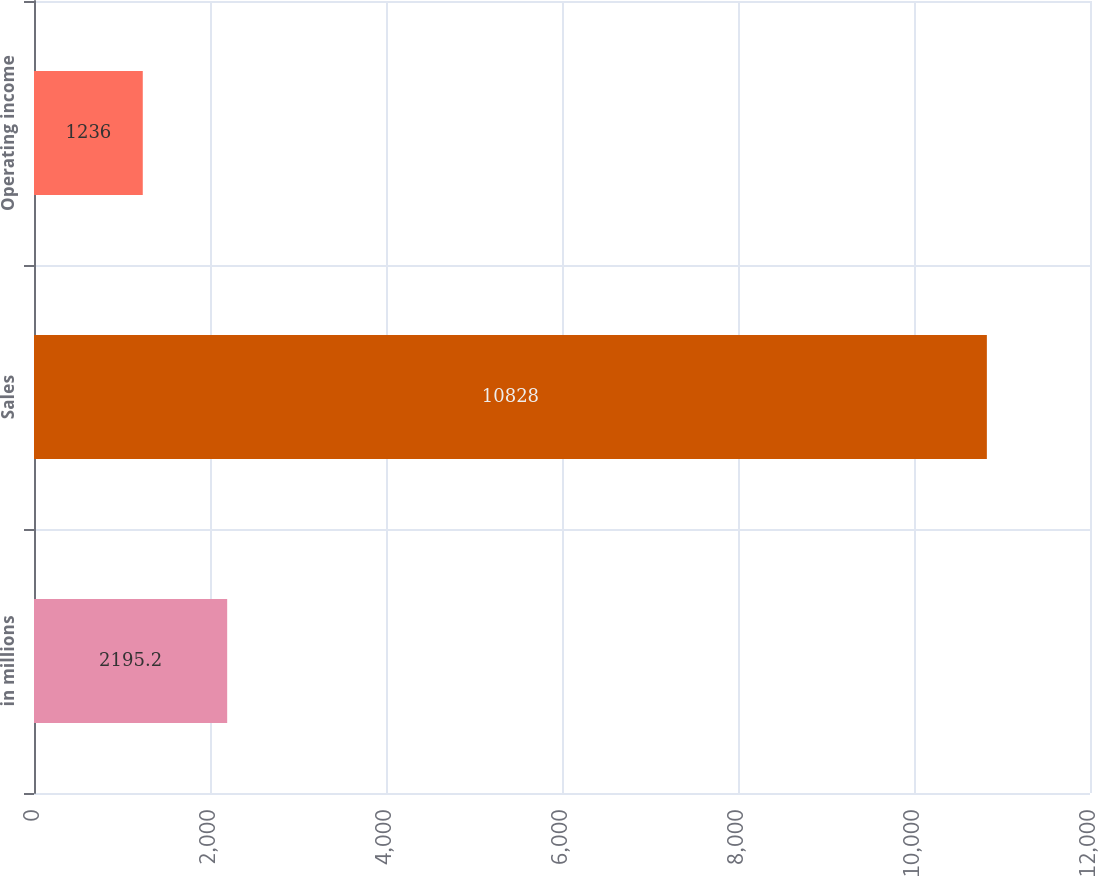Convert chart. <chart><loc_0><loc_0><loc_500><loc_500><bar_chart><fcel>in millions<fcel>Sales<fcel>Operating income<nl><fcel>2195.2<fcel>10828<fcel>1236<nl></chart> 